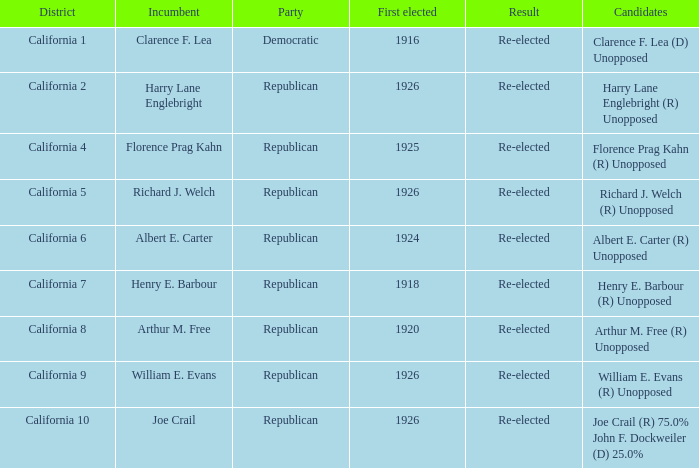What's the district with incumbent being richard j. welch California 5. 